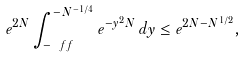<formula> <loc_0><loc_0><loc_500><loc_500>e ^ { 2 N } \int _ { - \ f f } ^ { - N ^ { - 1 / 4 } } e ^ { - y ^ { 2 } N } \, d y \leq e ^ { 2 N - N ^ { 1 / 2 } } ,</formula> 